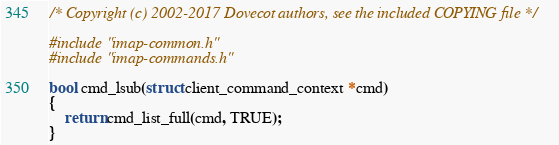<code> <loc_0><loc_0><loc_500><loc_500><_C_>/* Copyright (c) 2002-2017 Dovecot authors, see the included COPYING file */

#include "imap-common.h"
#include "imap-commands.h"

bool cmd_lsub(struct client_command_context *cmd)
{
	return cmd_list_full(cmd, TRUE);
}
</code> 